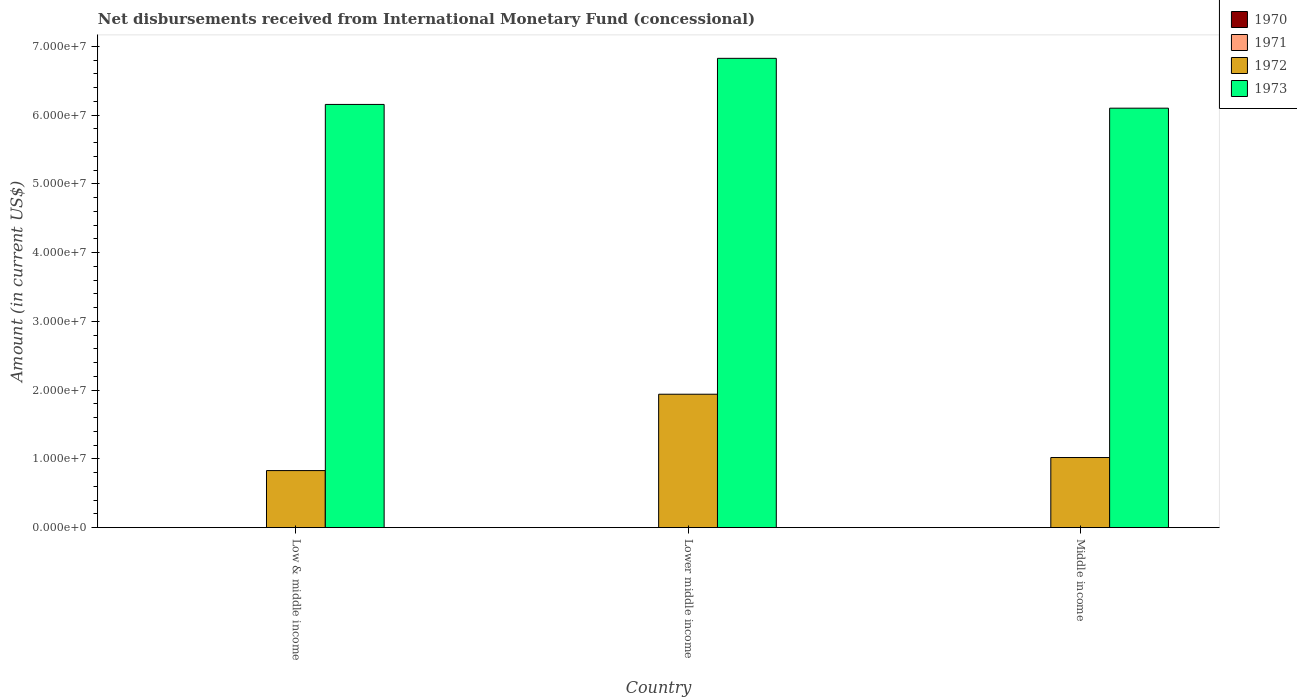How many different coloured bars are there?
Keep it short and to the point. 2. How many groups of bars are there?
Your answer should be very brief. 3. Are the number of bars per tick equal to the number of legend labels?
Provide a succinct answer. No. What is the label of the 2nd group of bars from the left?
Make the answer very short. Lower middle income. Across all countries, what is the maximum amount of disbursements received from International Monetary Fund in 1972?
Your answer should be compact. 1.94e+07. In which country was the amount of disbursements received from International Monetary Fund in 1972 maximum?
Offer a very short reply. Lower middle income. What is the total amount of disbursements received from International Monetary Fund in 1970 in the graph?
Your answer should be compact. 0. What is the difference between the amount of disbursements received from International Monetary Fund in 1973 in Low & middle income and that in Lower middle income?
Offer a terse response. -6.70e+06. What is the difference between the amount of disbursements received from International Monetary Fund in 1973 in Lower middle income and the amount of disbursements received from International Monetary Fund in 1971 in Low & middle income?
Offer a very short reply. 6.83e+07. What is the average amount of disbursements received from International Monetary Fund in 1973 per country?
Offer a very short reply. 6.36e+07. What is the difference between the amount of disbursements received from International Monetary Fund of/in 1973 and amount of disbursements received from International Monetary Fund of/in 1972 in Lower middle income?
Offer a terse response. 4.89e+07. What is the ratio of the amount of disbursements received from International Monetary Fund in 1972 in Low & middle income to that in Lower middle income?
Give a very brief answer. 0.43. Is the amount of disbursements received from International Monetary Fund in 1973 in Low & middle income less than that in Middle income?
Your answer should be compact. No. What is the difference between the highest and the second highest amount of disbursements received from International Monetary Fund in 1972?
Ensure brevity in your answer.  9.21e+06. What is the difference between the highest and the lowest amount of disbursements received from International Monetary Fund in 1973?
Your answer should be compact. 7.25e+06. Is the sum of the amount of disbursements received from International Monetary Fund in 1972 in Low & middle income and Middle income greater than the maximum amount of disbursements received from International Monetary Fund in 1973 across all countries?
Offer a terse response. No. Is it the case that in every country, the sum of the amount of disbursements received from International Monetary Fund in 1971 and amount of disbursements received from International Monetary Fund in 1972 is greater than the sum of amount of disbursements received from International Monetary Fund in 1973 and amount of disbursements received from International Monetary Fund in 1970?
Offer a terse response. No. How many bars are there?
Ensure brevity in your answer.  6. How many countries are there in the graph?
Provide a succinct answer. 3. Does the graph contain grids?
Offer a terse response. No. How many legend labels are there?
Offer a very short reply. 4. What is the title of the graph?
Provide a short and direct response. Net disbursements received from International Monetary Fund (concessional). Does "1964" appear as one of the legend labels in the graph?
Your answer should be compact. No. What is the label or title of the X-axis?
Provide a short and direct response. Country. What is the label or title of the Y-axis?
Make the answer very short. Amount (in current US$). What is the Amount (in current US$) in 1971 in Low & middle income?
Make the answer very short. 0. What is the Amount (in current US$) in 1972 in Low & middle income?
Offer a terse response. 8.30e+06. What is the Amount (in current US$) of 1973 in Low & middle income?
Your response must be concise. 6.16e+07. What is the Amount (in current US$) in 1972 in Lower middle income?
Ensure brevity in your answer.  1.94e+07. What is the Amount (in current US$) of 1973 in Lower middle income?
Give a very brief answer. 6.83e+07. What is the Amount (in current US$) of 1970 in Middle income?
Offer a very short reply. 0. What is the Amount (in current US$) of 1972 in Middle income?
Your answer should be very brief. 1.02e+07. What is the Amount (in current US$) of 1973 in Middle income?
Offer a terse response. 6.10e+07. Across all countries, what is the maximum Amount (in current US$) of 1972?
Offer a terse response. 1.94e+07. Across all countries, what is the maximum Amount (in current US$) in 1973?
Your answer should be compact. 6.83e+07. Across all countries, what is the minimum Amount (in current US$) in 1972?
Give a very brief answer. 8.30e+06. Across all countries, what is the minimum Amount (in current US$) of 1973?
Offer a terse response. 6.10e+07. What is the total Amount (in current US$) in 1970 in the graph?
Keep it short and to the point. 0. What is the total Amount (in current US$) in 1971 in the graph?
Give a very brief answer. 0. What is the total Amount (in current US$) in 1972 in the graph?
Provide a short and direct response. 3.79e+07. What is the total Amount (in current US$) in 1973 in the graph?
Your answer should be compact. 1.91e+08. What is the difference between the Amount (in current US$) in 1972 in Low & middle income and that in Lower middle income?
Your answer should be compact. -1.11e+07. What is the difference between the Amount (in current US$) in 1973 in Low & middle income and that in Lower middle income?
Give a very brief answer. -6.70e+06. What is the difference between the Amount (in current US$) of 1972 in Low & middle income and that in Middle income?
Give a very brief answer. -1.90e+06. What is the difference between the Amount (in current US$) of 1973 in Low & middle income and that in Middle income?
Keep it short and to the point. 5.46e+05. What is the difference between the Amount (in current US$) of 1972 in Lower middle income and that in Middle income?
Your answer should be compact. 9.21e+06. What is the difference between the Amount (in current US$) of 1973 in Lower middle income and that in Middle income?
Give a very brief answer. 7.25e+06. What is the difference between the Amount (in current US$) of 1972 in Low & middle income and the Amount (in current US$) of 1973 in Lower middle income?
Your answer should be compact. -6.00e+07. What is the difference between the Amount (in current US$) in 1972 in Low & middle income and the Amount (in current US$) in 1973 in Middle income?
Your response must be concise. -5.27e+07. What is the difference between the Amount (in current US$) in 1972 in Lower middle income and the Amount (in current US$) in 1973 in Middle income?
Give a very brief answer. -4.16e+07. What is the average Amount (in current US$) of 1972 per country?
Your answer should be compact. 1.26e+07. What is the average Amount (in current US$) in 1973 per country?
Provide a short and direct response. 6.36e+07. What is the difference between the Amount (in current US$) in 1972 and Amount (in current US$) in 1973 in Low & middle income?
Provide a short and direct response. -5.33e+07. What is the difference between the Amount (in current US$) in 1972 and Amount (in current US$) in 1973 in Lower middle income?
Offer a terse response. -4.89e+07. What is the difference between the Amount (in current US$) of 1972 and Amount (in current US$) of 1973 in Middle income?
Provide a short and direct response. -5.08e+07. What is the ratio of the Amount (in current US$) of 1972 in Low & middle income to that in Lower middle income?
Ensure brevity in your answer.  0.43. What is the ratio of the Amount (in current US$) in 1973 in Low & middle income to that in Lower middle income?
Give a very brief answer. 0.9. What is the ratio of the Amount (in current US$) in 1972 in Low & middle income to that in Middle income?
Your answer should be very brief. 0.81. What is the ratio of the Amount (in current US$) in 1972 in Lower middle income to that in Middle income?
Keep it short and to the point. 1.9. What is the ratio of the Amount (in current US$) in 1973 in Lower middle income to that in Middle income?
Offer a terse response. 1.12. What is the difference between the highest and the second highest Amount (in current US$) of 1972?
Make the answer very short. 9.21e+06. What is the difference between the highest and the second highest Amount (in current US$) of 1973?
Your answer should be very brief. 6.70e+06. What is the difference between the highest and the lowest Amount (in current US$) in 1972?
Give a very brief answer. 1.11e+07. What is the difference between the highest and the lowest Amount (in current US$) of 1973?
Provide a short and direct response. 7.25e+06. 